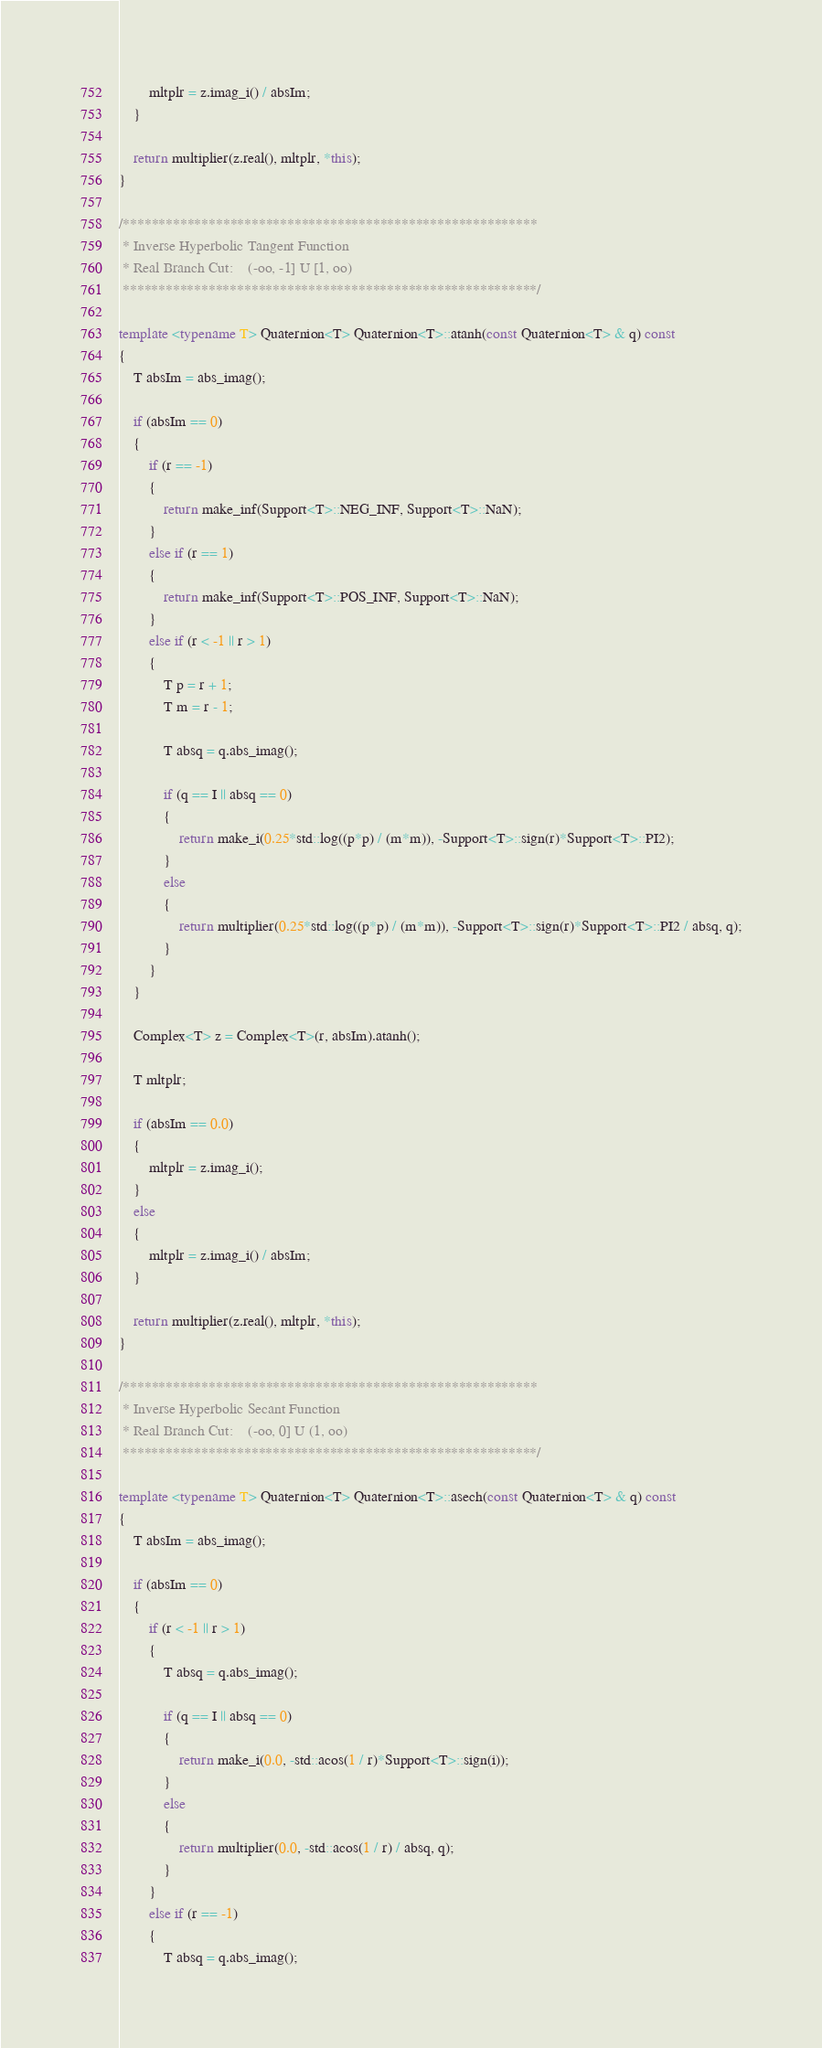<code> <loc_0><loc_0><loc_500><loc_500><_C++_>        mltplr = z.imag_i() / absIm;
    }

    return multiplier(z.real(), mltplr, *this);
}

/**********************************************************
 * Inverse Hyperbolic Tangent Function
 * Real Branch Cut:    (-oo, -1] U [1, oo)
 **********************************************************/

template <typename T> Quaternion<T> Quaternion<T>::atanh(const Quaternion<T> & q) const
{
    T absIm = abs_imag();

    if (absIm == 0)
    {
        if (r == -1)
        {
            return make_inf(Support<T>::NEG_INF, Support<T>::NaN);
        }
        else if (r == 1)
        {
            return make_inf(Support<T>::POS_INF, Support<T>::NaN);
        }
        else if (r < -1 || r > 1)
        {
            T p = r + 1;
            T m = r - 1;

            T absq = q.abs_imag();

            if (q == I || absq == 0)
            {
                return make_i(0.25*std::log((p*p) / (m*m)), -Support<T>::sign(r)*Support<T>::PI2);
            }
            else
            {
                return multiplier(0.25*std::log((p*p) / (m*m)), -Support<T>::sign(r)*Support<T>::PI2 / absq, q);
            }
        }
    }

    Complex<T> z = Complex<T>(r, absIm).atanh();

    T mltplr;

    if (absIm == 0.0)
    {
        mltplr = z.imag_i();
    }
    else
    {
        mltplr = z.imag_i() / absIm;
    }

    return multiplier(z.real(), mltplr, *this);
}

/**********************************************************
 * Inverse Hyperbolic Secant Function
 * Real Branch Cut:    (-oo, 0] U (1, oo)
 **********************************************************/

template <typename T> Quaternion<T> Quaternion<T>::asech(const Quaternion<T> & q) const
{
    T absIm = abs_imag();

    if (absIm == 0)
    {
        if (r < -1 || r > 1)
        {
            T absq = q.abs_imag();

            if (q == I || absq == 0)
            {
                return make_i(0.0, -std::acos(1 / r)*Support<T>::sign(i));
            }
            else
            {
                return multiplier(0.0, -std::acos(1 / r) / absq, q);
            }
        }
        else if (r == -1)
        {
            T absq = q.abs_imag();
</code> 